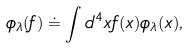Convert formula to latex. <formula><loc_0><loc_0><loc_500><loc_500>\phi _ { \lambda } ( f ) \doteq \int d ^ { 4 } x f ( x ) \phi _ { \lambda } ( x ) ,</formula> 